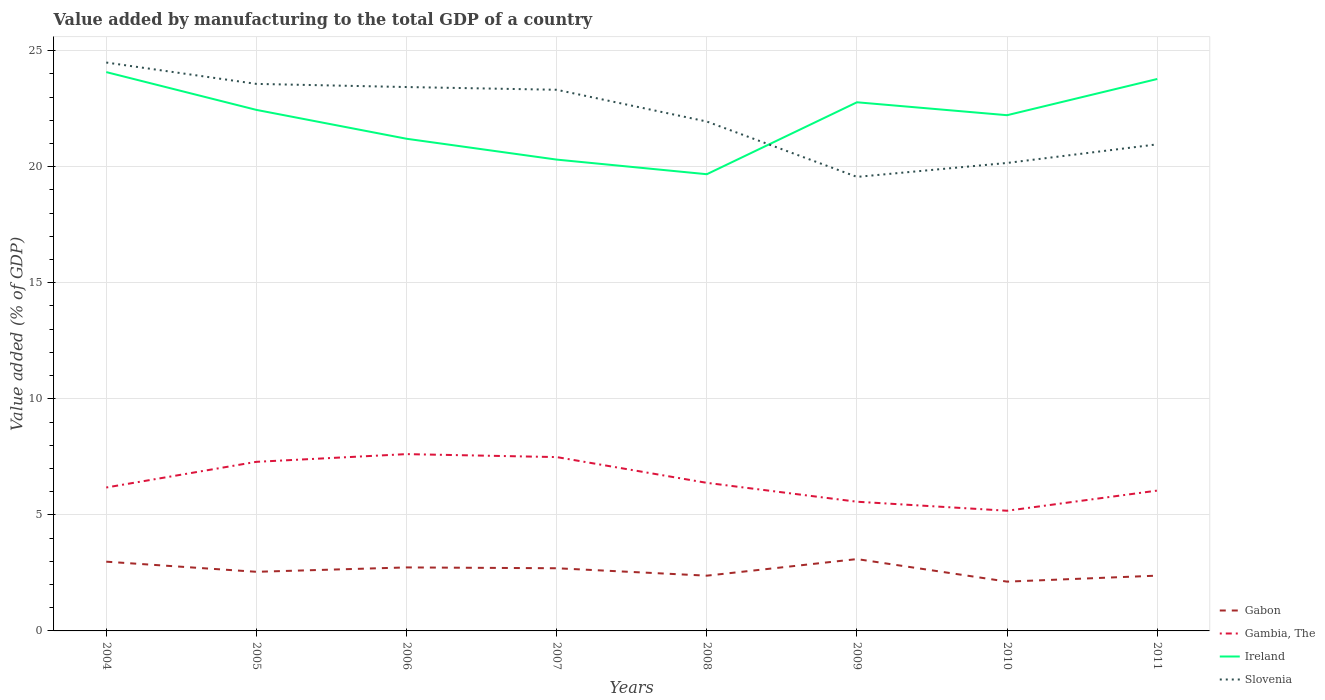How many different coloured lines are there?
Provide a short and direct response. 4. Does the line corresponding to Gambia, The intersect with the line corresponding to Slovenia?
Your answer should be compact. No. Across all years, what is the maximum value added by manufacturing to the total GDP in Gambia, The?
Offer a terse response. 5.18. What is the total value added by manufacturing to the total GDP in Ireland in the graph?
Your answer should be compact. 1.53. What is the difference between the highest and the second highest value added by manufacturing to the total GDP in Gambia, The?
Give a very brief answer. 2.44. Is the value added by manufacturing to the total GDP in Ireland strictly greater than the value added by manufacturing to the total GDP in Gambia, The over the years?
Offer a very short reply. No. How many lines are there?
Your answer should be very brief. 4. How many years are there in the graph?
Ensure brevity in your answer.  8. Are the values on the major ticks of Y-axis written in scientific E-notation?
Your response must be concise. No. Does the graph contain any zero values?
Your answer should be very brief. No. Does the graph contain grids?
Your answer should be very brief. Yes. How many legend labels are there?
Your answer should be very brief. 4. What is the title of the graph?
Give a very brief answer. Value added by manufacturing to the total GDP of a country. Does "Liberia" appear as one of the legend labels in the graph?
Provide a short and direct response. No. What is the label or title of the Y-axis?
Your answer should be very brief. Value added (% of GDP). What is the Value added (% of GDP) of Gabon in 2004?
Offer a terse response. 2.98. What is the Value added (% of GDP) of Gambia, The in 2004?
Keep it short and to the point. 6.18. What is the Value added (% of GDP) in Ireland in 2004?
Provide a succinct answer. 24.07. What is the Value added (% of GDP) in Slovenia in 2004?
Ensure brevity in your answer.  24.49. What is the Value added (% of GDP) of Gabon in 2005?
Provide a short and direct response. 2.55. What is the Value added (% of GDP) in Gambia, The in 2005?
Provide a short and direct response. 7.28. What is the Value added (% of GDP) in Ireland in 2005?
Your answer should be compact. 22.45. What is the Value added (% of GDP) of Slovenia in 2005?
Your answer should be very brief. 23.57. What is the Value added (% of GDP) of Gabon in 2006?
Offer a very short reply. 2.74. What is the Value added (% of GDP) of Gambia, The in 2006?
Provide a short and direct response. 7.62. What is the Value added (% of GDP) in Ireland in 2006?
Make the answer very short. 21.2. What is the Value added (% of GDP) of Slovenia in 2006?
Offer a terse response. 23.43. What is the Value added (% of GDP) in Gabon in 2007?
Your answer should be very brief. 2.7. What is the Value added (% of GDP) of Gambia, The in 2007?
Your answer should be very brief. 7.49. What is the Value added (% of GDP) in Ireland in 2007?
Make the answer very short. 20.31. What is the Value added (% of GDP) in Slovenia in 2007?
Offer a very short reply. 23.31. What is the Value added (% of GDP) in Gabon in 2008?
Offer a very short reply. 2.38. What is the Value added (% of GDP) of Gambia, The in 2008?
Ensure brevity in your answer.  6.38. What is the Value added (% of GDP) of Ireland in 2008?
Your response must be concise. 19.68. What is the Value added (% of GDP) in Slovenia in 2008?
Provide a short and direct response. 21.95. What is the Value added (% of GDP) in Gabon in 2009?
Make the answer very short. 3.1. What is the Value added (% of GDP) of Gambia, The in 2009?
Keep it short and to the point. 5.57. What is the Value added (% of GDP) of Ireland in 2009?
Offer a very short reply. 22.77. What is the Value added (% of GDP) in Slovenia in 2009?
Ensure brevity in your answer.  19.56. What is the Value added (% of GDP) in Gabon in 2010?
Your answer should be compact. 2.12. What is the Value added (% of GDP) in Gambia, The in 2010?
Keep it short and to the point. 5.18. What is the Value added (% of GDP) of Ireland in 2010?
Your answer should be very brief. 22.22. What is the Value added (% of GDP) of Slovenia in 2010?
Give a very brief answer. 20.16. What is the Value added (% of GDP) in Gabon in 2011?
Make the answer very short. 2.38. What is the Value added (% of GDP) in Gambia, The in 2011?
Ensure brevity in your answer.  6.05. What is the Value added (% of GDP) in Ireland in 2011?
Offer a very short reply. 23.78. What is the Value added (% of GDP) of Slovenia in 2011?
Offer a very short reply. 20.96. Across all years, what is the maximum Value added (% of GDP) of Gabon?
Your response must be concise. 3.1. Across all years, what is the maximum Value added (% of GDP) of Gambia, The?
Your answer should be compact. 7.62. Across all years, what is the maximum Value added (% of GDP) in Ireland?
Offer a terse response. 24.07. Across all years, what is the maximum Value added (% of GDP) of Slovenia?
Give a very brief answer. 24.49. Across all years, what is the minimum Value added (% of GDP) of Gabon?
Give a very brief answer. 2.12. Across all years, what is the minimum Value added (% of GDP) of Gambia, The?
Provide a short and direct response. 5.18. Across all years, what is the minimum Value added (% of GDP) of Ireland?
Ensure brevity in your answer.  19.68. Across all years, what is the minimum Value added (% of GDP) in Slovenia?
Ensure brevity in your answer.  19.56. What is the total Value added (% of GDP) of Gabon in the graph?
Offer a very short reply. 20.95. What is the total Value added (% of GDP) in Gambia, The in the graph?
Your answer should be very brief. 51.74. What is the total Value added (% of GDP) in Ireland in the graph?
Ensure brevity in your answer.  176.47. What is the total Value added (% of GDP) of Slovenia in the graph?
Make the answer very short. 177.43. What is the difference between the Value added (% of GDP) in Gabon in 2004 and that in 2005?
Your response must be concise. 0.44. What is the difference between the Value added (% of GDP) of Gambia, The in 2004 and that in 2005?
Offer a very short reply. -1.11. What is the difference between the Value added (% of GDP) of Ireland in 2004 and that in 2005?
Keep it short and to the point. 1.63. What is the difference between the Value added (% of GDP) in Slovenia in 2004 and that in 2005?
Make the answer very short. 0.92. What is the difference between the Value added (% of GDP) of Gabon in 2004 and that in 2006?
Give a very brief answer. 0.25. What is the difference between the Value added (% of GDP) in Gambia, The in 2004 and that in 2006?
Your answer should be very brief. -1.44. What is the difference between the Value added (% of GDP) of Ireland in 2004 and that in 2006?
Your answer should be compact. 2.87. What is the difference between the Value added (% of GDP) of Slovenia in 2004 and that in 2006?
Make the answer very short. 1.06. What is the difference between the Value added (% of GDP) of Gabon in 2004 and that in 2007?
Offer a terse response. 0.28. What is the difference between the Value added (% of GDP) of Gambia, The in 2004 and that in 2007?
Offer a terse response. -1.31. What is the difference between the Value added (% of GDP) of Ireland in 2004 and that in 2007?
Provide a succinct answer. 3.77. What is the difference between the Value added (% of GDP) of Slovenia in 2004 and that in 2007?
Provide a short and direct response. 1.17. What is the difference between the Value added (% of GDP) of Gabon in 2004 and that in 2008?
Ensure brevity in your answer.  0.6. What is the difference between the Value added (% of GDP) in Gambia, The in 2004 and that in 2008?
Keep it short and to the point. -0.2. What is the difference between the Value added (% of GDP) of Ireland in 2004 and that in 2008?
Provide a succinct answer. 4.4. What is the difference between the Value added (% of GDP) in Slovenia in 2004 and that in 2008?
Offer a very short reply. 2.54. What is the difference between the Value added (% of GDP) of Gabon in 2004 and that in 2009?
Your answer should be very brief. -0.11. What is the difference between the Value added (% of GDP) in Gambia, The in 2004 and that in 2009?
Your answer should be compact. 0.61. What is the difference between the Value added (% of GDP) in Ireland in 2004 and that in 2009?
Provide a succinct answer. 1.3. What is the difference between the Value added (% of GDP) in Slovenia in 2004 and that in 2009?
Your answer should be very brief. 4.93. What is the difference between the Value added (% of GDP) in Gabon in 2004 and that in 2010?
Your answer should be very brief. 0.86. What is the difference between the Value added (% of GDP) of Ireland in 2004 and that in 2010?
Provide a succinct answer. 1.86. What is the difference between the Value added (% of GDP) in Slovenia in 2004 and that in 2010?
Offer a very short reply. 4.33. What is the difference between the Value added (% of GDP) of Gabon in 2004 and that in 2011?
Offer a very short reply. 0.6. What is the difference between the Value added (% of GDP) in Gambia, The in 2004 and that in 2011?
Your response must be concise. 0.13. What is the difference between the Value added (% of GDP) of Ireland in 2004 and that in 2011?
Offer a terse response. 0.3. What is the difference between the Value added (% of GDP) in Slovenia in 2004 and that in 2011?
Offer a terse response. 3.52. What is the difference between the Value added (% of GDP) in Gabon in 2005 and that in 2006?
Provide a short and direct response. -0.19. What is the difference between the Value added (% of GDP) in Gambia, The in 2005 and that in 2006?
Provide a short and direct response. -0.33. What is the difference between the Value added (% of GDP) in Ireland in 2005 and that in 2006?
Your response must be concise. 1.24. What is the difference between the Value added (% of GDP) in Slovenia in 2005 and that in 2006?
Give a very brief answer. 0.14. What is the difference between the Value added (% of GDP) in Gabon in 2005 and that in 2007?
Make the answer very short. -0.15. What is the difference between the Value added (% of GDP) in Gambia, The in 2005 and that in 2007?
Your answer should be very brief. -0.2. What is the difference between the Value added (% of GDP) in Ireland in 2005 and that in 2007?
Your response must be concise. 2.14. What is the difference between the Value added (% of GDP) in Slovenia in 2005 and that in 2007?
Your answer should be compact. 0.25. What is the difference between the Value added (% of GDP) of Gabon in 2005 and that in 2008?
Give a very brief answer. 0.17. What is the difference between the Value added (% of GDP) of Gambia, The in 2005 and that in 2008?
Offer a very short reply. 0.91. What is the difference between the Value added (% of GDP) in Ireland in 2005 and that in 2008?
Offer a terse response. 2.77. What is the difference between the Value added (% of GDP) in Slovenia in 2005 and that in 2008?
Your response must be concise. 1.62. What is the difference between the Value added (% of GDP) in Gabon in 2005 and that in 2009?
Make the answer very short. -0.55. What is the difference between the Value added (% of GDP) in Gambia, The in 2005 and that in 2009?
Offer a terse response. 1.72. What is the difference between the Value added (% of GDP) of Ireland in 2005 and that in 2009?
Offer a very short reply. -0.33. What is the difference between the Value added (% of GDP) of Slovenia in 2005 and that in 2009?
Provide a succinct answer. 4.01. What is the difference between the Value added (% of GDP) of Gabon in 2005 and that in 2010?
Your answer should be very brief. 0.42. What is the difference between the Value added (% of GDP) of Gambia, The in 2005 and that in 2010?
Give a very brief answer. 2.11. What is the difference between the Value added (% of GDP) in Ireland in 2005 and that in 2010?
Your answer should be very brief. 0.23. What is the difference between the Value added (% of GDP) in Slovenia in 2005 and that in 2010?
Give a very brief answer. 3.41. What is the difference between the Value added (% of GDP) of Gabon in 2005 and that in 2011?
Provide a short and direct response. 0.17. What is the difference between the Value added (% of GDP) in Gambia, The in 2005 and that in 2011?
Your answer should be compact. 1.24. What is the difference between the Value added (% of GDP) in Ireland in 2005 and that in 2011?
Your answer should be compact. -1.33. What is the difference between the Value added (% of GDP) of Slovenia in 2005 and that in 2011?
Your response must be concise. 2.6. What is the difference between the Value added (% of GDP) in Gabon in 2006 and that in 2007?
Provide a succinct answer. 0.04. What is the difference between the Value added (% of GDP) of Gambia, The in 2006 and that in 2007?
Ensure brevity in your answer.  0.13. What is the difference between the Value added (% of GDP) in Ireland in 2006 and that in 2007?
Make the answer very short. 0.9. What is the difference between the Value added (% of GDP) in Slovenia in 2006 and that in 2007?
Your response must be concise. 0.12. What is the difference between the Value added (% of GDP) of Gabon in 2006 and that in 2008?
Give a very brief answer. 0.36. What is the difference between the Value added (% of GDP) in Gambia, The in 2006 and that in 2008?
Provide a succinct answer. 1.24. What is the difference between the Value added (% of GDP) of Ireland in 2006 and that in 2008?
Make the answer very short. 1.53. What is the difference between the Value added (% of GDP) of Slovenia in 2006 and that in 2008?
Your answer should be very brief. 1.49. What is the difference between the Value added (% of GDP) of Gabon in 2006 and that in 2009?
Offer a very short reply. -0.36. What is the difference between the Value added (% of GDP) in Gambia, The in 2006 and that in 2009?
Offer a terse response. 2.05. What is the difference between the Value added (% of GDP) of Ireland in 2006 and that in 2009?
Your response must be concise. -1.57. What is the difference between the Value added (% of GDP) of Slovenia in 2006 and that in 2009?
Your response must be concise. 3.87. What is the difference between the Value added (% of GDP) of Gabon in 2006 and that in 2010?
Your response must be concise. 0.61. What is the difference between the Value added (% of GDP) of Gambia, The in 2006 and that in 2010?
Give a very brief answer. 2.44. What is the difference between the Value added (% of GDP) of Ireland in 2006 and that in 2010?
Your answer should be very brief. -1.01. What is the difference between the Value added (% of GDP) of Slovenia in 2006 and that in 2010?
Ensure brevity in your answer.  3.27. What is the difference between the Value added (% of GDP) of Gabon in 2006 and that in 2011?
Keep it short and to the point. 0.35. What is the difference between the Value added (% of GDP) in Gambia, The in 2006 and that in 2011?
Offer a terse response. 1.57. What is the difference between the Value added (% of GDP) in Ireland in 2006 and that in 2011?
Your response must be concise. -2.57. What is the difference between the Value added (% of GDP) in Slovenia in 2006 and that in 2011?
Offer a very short reply. 2.47. What is the difference between the Value added (% of GDP) of Gabon in 2007 and that in 2008?
Your response must be concise. 0.32. What is the difference between the Value added (% of GDP) in Gambia, The in 2007 and that in 2008?
Your answer should be very brief. 1.11. What is the difference between the Value added (% of GDP) of Ireland in 2007 and that in 2008?
Your answer should be very brief. 0.63. What is the difference between the Value added (% of GDP) in Slovenia in 2007 and that in 2008?
Make the answer very short. 1.37. What is the difference between the Value added (% of GDP) in Gabon in 2007 and that in 2009?
Your answer should be compact. -0.4. What is the difference between the Value added (% of GDP) of Gambia, The in 2007 and that in 2009?
Your answer should be very brief. 1.92. What is the difference between the Value added (% of GDP) in Ireland in 2007 and that in 2009?
Give a very brief answer. -2.47. What is the difference between the Value added (% of GDP) in Slovenia in 2007 and that in 2009?
Make the answer very short. 3.75. What is the difference between the Value added (% of GDP) in Gabon in 2007 and that in 2010?
Provide a succinct answer. 0.58. What is the difference between the Value added (% of GDP) in Gambia, The in 2007 and that in 2010?
Your answer should be compact. 2.31. What is the difference between the Value added (% of GDP) in Ireland in 2007 and that in 2010?
Keep it short and to the point. -1.91. What is the difference between the Value added (% of GDP) in Slovenia in 2007 and that in 2010?
Give a very brief answer. 3.15. What is the difference between the Value added (% of GDP) of Gabon in 2007 and that in 2011?
Provide a short and direct response. 0.32. What is the difference between the Value added (% of GDP) in Gambia, The in 2007 and that in 2011?
Offer a terse response. 1.44. What is the difference between the Value added (% of GDP) in Ireland in 2007 and that in 2011?
Give a very brief answer. -3.47. What is the difference between the Value added (% of GDP) in Slovenia in 2007 and that in 2011?
Ensure brevity in your answer.  2.35. What is the difference between the Value added (% of GDP) in Gabon in 2008 and that in 2009?
Your answer should be very brief. -0.71. What is the difference between the Value added (% of GDP) of Gambia, The in 2008 and that in 2009?
Provide a succinct answer. 0.81. What is the difference between the Value added (% of GDP) in Ireland in 2008 and that in 2009?
Your answer should be compact. -3.1. What is the difference between the Value added (% of GDP) of Slovenia in 2008 and that in 2009?
Give a very brief answer. 2.39. What is the difference between the Value added (% of GDP) of Gabon in 2008 and that in 2010?
Provide a succinct answer. 0.26. What is the difference between the Value added (% of GDP) of Gambia, The in 2008 and that in 2010?
Offer a very short reply. 1.2. What is the difference between the Value added (% of GDP) in Ireland in 2008 and that in 2010?
Provide a succinct answer. -2.54. What is the difference between the Value added (% of GDP) of Slovenia in 2008 and that in 2010?
Provide a succinct answer. 1.78. What is the difference between the Value added (% of GDP) of Gabon in 2008 and that in 2011?
Make the answer very short. -0. What is the difference between the Value added (% of GDP) in Gambia, The in 2008 and that in 2011?
Give a very brief answer. 0.33. What is the difference between the Value added (% of GDP) of Ireland in 2008 and that in 2011?
Make the answer very short. -4.1. What is the difference between the Value added (% of GDP) of Slovenia in 2008 and that in 2011?
Your answer should be compact. 0.98. What is the difference between the Value added (% of GDP) of Gabon in 2009 and that in 2010?
Provide a short and direct response. 0.97. What is the difference between the Value added (% of GDP) in Gambia, The in 2009 and that in 2010?
Ensure brevity in your answer.  0.39. What is the difference between the Value added (% of GDP) in Ireland in 2009 and that in 2010?
Your answer should be very brief. 0.56. What is the difference between the Value added (% of GDP) in Slovenia in 2009 and that in 2010?
Offer a terse response. -0.6. What is the difference between the Value added (% of GDP) in Gabon in 2009 and that in 2011?
Your answer should be very brief. 0.71. What is the difference between the Value added (% of GDP) in Gambia, The in 2009 and that in 2011?
Make the answer very short. -0.48. What is the difference between the Value added (% of GDP) of Ireland in 2009 and that in 2011?
Give a very brief answer. -1. What is the difference between the Value added (% of GDP) in Slovenia in 2009 and that in 2011?
Offer a terse response. -1.4. What is the difference between the Value added (% of GDP) in Gabon in 2010 and that in 2011?
Your response must be concise. -0.26. What is the difference between the Value added (% of GDP) in Gambia, The in 2010 and that in 2011?
Offer a very short reply. -0.87. What is the difference between the Value added (% of GDP) of Ireland in 2010 and that in 2011?
Provide a succinct answer. -1.56. What is the difference between the Value added (% of GDP) of Slovenia in 2010 and that in 2011?
Ensure brevity in your answer.  -0.8. What is the difference between the Value added (% of GDP) in Gabon in 2004 and the Value added (% of GDP) in Gambia, The in 2005?
Offer a very short reply. -4.3. What is the difference between the Value added (% of GDP) in Gabon in 2004 and the Value added (% of GDP) in Ireland in 2005?
Keep it short and to the point. -19.46. What is the difference between the Value added (% of GDP) of Gabon in 2004 and the Value added (% of GDP) of Slovenia in 2005?
Offer a very short reply. -20.58. What is the difference between the Value added (% of GDP) in Gambia, The in 2004 and the Value added (% of GDP) in Ireland in 2005?
Offer a terse response. -16.27. What is the difference between the Value added (% of GDP) in Gambia, The in 2004 and the Value added (% of GDP) in Slovenia in 2005?
Offer a terse response. -17.39. What is the difference between the Value added (% of GDP) of Ireland in 2004 and the Value added (% of GDP) of Slovenia in 2005?
Your answer should be very brief. 0.51. What is the difference between the Value added (% of GDP) of Gabon in 2004 and the Value added (% of GDP) of Gambia, The in 2006?
Your response must be concise. -4.63. What is the difference between the Value added (% of GDP) in Gabon in 2004 and the Value added (% of GDP) in Ireland in 2006?
Give a very brief answer. -18.22. What is the difference between the Value added (% of GDP) in Gabon in 2004 and the Value added (% of GDP) in Slovenia in 2006?
Provide a short and direct response. -20.45. What is the difference between the Value added (% of GDP) of Gambia, The in 2004 and the Value added (% of GDP) of Ireland in 2006?
Your answer should be very brief. -15.02. What is the difference between the Value added (% of GDP) in Gambia, The in 2004 and the Value added (% of GDP) in Slovenia in 2006?
Provide a short and direct response. -17.25. What is the difference between the Value added (% of GDP) of Ireland in 2004 and the Value added (% of GDP) of Slovenia in 2006?
Provide a short and direct response. 0.64. What is the difference between the Value added (% of GDP) in Gabon in 2004 and the Value added (% of GDP) in Gambia, The in 2007?
Make the answer very short. -4.51. What is the difference between the Value added (% of GDP) of Gabon in 2004 and the Value added (% of GDP) of Ireland in 2007?
Give a very brief answer. -17.32. What is the difference between the Value added (% of GDP) of Gabon in 2004 and the Value added (% of GDP) of Slovenia in 2007?
Ensure brevity in your answer.  -20.33. What is the difference between the Value added (% of GDP) of Gambia, The in 2004 and the Value added (% of GDP) of Ireland in 2007?
Make the answer very short. -14.13. What is the difference between the Value added (% of GDP) of Gambia, The in 2004 and the Value added (% of GDP) of Slovenia in 2007?
Make the answer very short. -17.14. What is the difference between the Value added (% of GDP) of Ireland in 2004 and the Value added (% of GDP) of Slovenia in 2007?
Make the answer very short. 0.76. What is the difference between the Value added (% of GDP) in Gabon in 2004 and the Value added (% of GDP) in Gambia, The in 2008?
Your response must be concise. -3.4. What is the difference between the Value added (% of GDP) in Gabon in 2004 and the Value added (% of GDP) in Ireland in 2008?
Offer a terse response. -16.69. What is the difference between the Value added (% of GDP) of Gabon in 2004 and the Value added (% of GDP) of Slovenia in 2008?
Make the answer very short. -18.96. What is the difference between the Value added (% of GDP) of Gambia, The in 2004 and the Value added (% of GDP) of Ireland in 2008?
Provide a short and direct response. -13.5. What is the difference between the Value added (% of GDP) of Gambia, The in 2004 and the Value added (% of GDP) of Slovenia in 2008?
Your response must be concise. -15.77. What is the difference between the Value added (% of GDP) in Ireland in 2004 and the Value added (% of GDP) in Slovenia in 2008?
Provide a short and direct response. 2.13. What is the difference between the Value added (% of GDP) of Gabon in 2004 and the Value added (% of GDP) of Gambia, The in 2009?
Your response must be concise. -2.58. What is the difference between the Value added (% of GDP) in Gabon in 2004 and the Value added (% of GDP) in Ireland in 2009?
Make the answer very short. -19.79. What is the difference between the Value added (% of GDP) of Gabon in 2004 and the Value added (% of GDP) of Slovenia in 2009?
Make the answer very short. -16.58. What is the difference between the Value added (% of GDP) in Gambia, The in 2004 and the Value added (% of GDP) in Ireland in 2009?
Your answer should be very brief. -16.6. What is the difference between the Value added (% of GDP) in Gambia, The in 2004 and the Value added (% of GDP) in Slovenia in 2009?
Provide a short and direct response. -13.38. What is the difference between the Value added (% of GDP) in Ireland in 2004 and the Value added (% of GDP) in Slovenia in 2009?
Offer a very short reply. 4.51. What is the difference between the Value added (% of GDP) of Gabon in 2004 and the Value added (% of GDP) of Gambia, The in 2010?
Provide a short and direct response. -2.19. What is the difference between the Value added (% of GDP) in Gabon in 2004 and the Value added (% of GDP) in Ireland in 2010?
Your answer should be very brief. -19.23. What is the difference between the Value added (% of GDP) of Gabon in 2004 and the Value added (% of GDP) of Slovenia in 2010?
Keep it short and to the point. -17.18. What is the difference between the Value added (% of GDP) in Gambia, The in 2004 and the Value added (% of GDP) in Ireland in 2010?
Make the answer very short. -16.04. What is the difference between the Value added (% of GDP) in Gambia, The in 2004 and the Value added (% of GDP) in Slovenia in 2010?
Offer a terse response. -13.98. What is the difference between the Value added (% of GDP) of Ireland in 2004 and the Value added (% of GDP) of Slovenia in 2010?
Your response must be concise. 3.91. What is the difference between the Value added (% of GDP) of Gabon in 2004 and the Value added (% of GDP) of Gambia, The in 2011?
Ensure brevity in your answer.  -3.06. What is the difference between the Value added (% of GDP) of Gabon in 2004 and the Value added (% of GDP) of Ireland in 2011?
Ensure brevity in your answer.  -20.79. What is the difference between the Value added (% of GDP) of Gabon in 2004 and the Value added (% of GDP) of Slovenia in 2011?
Offer a terse response. -17.98. What is the difference between the Value added (% of GDP) of Gambia, The in 2004 and the Value added (% of GDP) of Ireland in 2011?
Your answer should be compact. -17.6. What is the difference between the Value added (% of GDP) of Gambia, The in 2004 and the Value added (% of GDP) of Slovenia in 2011?
Give a very brief answer. -14.78. What is the difference between the Value added (% of GDP) of Ireland in 2004 and the Value added (% of GDP) of Slovenia in 2011?
Provide a short and direct response. 3.11. What is the difference between the Value added (% of GDP) in Gabon in 2005 and the Value added (% of GDP) in Gambia, The in 2006?
Offer a terse response. -5.07. What is the difference between the Value added (% of GDP) of Gabon in 2005 and the Value added (% of GDP) of Ireland in 2006?
Ensure brevity in your answer.  -18.66. What is the difference between the Value added (% of GDP) of Gabon in 2005 and the Value added (% of GDP) of Slovenia in 2006?
Make the answer very short. -20.88. What is the difference between the Value added (% of GDP) of Gambia, The in 2005 and the Value added (% of GDP) of Ireland in 2006?
Give a very brief answer. -13.92. What is the difference between the Value added (% of GDP) in Gambia, The in 2005 and the Value added (% of GDP) in Slovenia in 2006?
Offer a terse response. -16.15. What is the difference between the Value added (% of GDP) in Ireland in 2005 and the Value added (% of GDP) in Slovenia in 2006?
Provide a succinct answer. -0.98. What is the difference between the Value added (% of GDP) in Gabon in 2005 and the Value added (% of GDP) in Gambia, The in 2007?
Your answer should be compact. -4.94. What is the difference between the Value added (% of GDP) of Gabon in 2005 and the Value added (% of GDP) of Ireland in 2007?
Offer a very short reply. -17.76. What is the difference between the Value added (% of GDP) in Gabon in 2005 and the Value added (% of GDP) in Slovenia in 2007?
Provide a short and direct response. -20.77. What is the difference between the Value added (% of GDP) in Gambia, The in 2005 and the Value added (% of GDP) in Ireland in 2007?
Keep it short and to the point. -13.02. What is the difference between the Value added (% of GDP) in Gambia, The in 2005 and the Value added (% of GDP) in Slovenia in 2007?
Offer a very short reply. -16.03. What is the difference between the Value added (% of GDP) in Ireland in 2005 and the Value added (% of GDP) in Slovenia in 2007?
Provide a succinct answer. -0.87. What is the difference between the Value added (% of GDP) in Gabon in 2005 and the Value added (% of GDP) in Gambia, The in 2008?
Ensure brevity in your answer.  -3.83. What is the difference between the Value added (% of GDP) in Gabon in 2005 and the Value added (% of GDP) in Ireland in 2008?
Your response must be concise. -17.13. What is the difference between the Value added (% of GDP) of Gabon in 2005 and the Value added (% of GDP) of Slovenia in 2008?
Make the answer very short. -19.4. What is the difference between the Value added (% of GDP) in Gambia, The in 2005 and the Value added (% of GDP) in Ireland in 2008?
Provide a succinct answer. -12.39. What is the difference between the Value added (% of GDP) in Gambia, The in 2005 and the Value added (% of GDP) in Slovenia in 2008?
Offer a very short reply. -14.66. What is the difference between the Value added (% of GDP) in Ireland in 2005 and the Value added (% of GDP) in Slovenia in 2008?
Keep it short and to the point. 0.5. What is the difference between the Value added (% of GDP) in Gabon in 2005 and the Value added (% of GDP) in Gambia, The in 2009?
Provide a short and direct response. -3.02. What is the difference between the Value added (% of GDP) of Gabon in 2005 and the Value added (% of GDP) of Ireland in 2009?
Your answer should be compact. -20.23. What is the difference between the Value added (% of GDP) in Gabon in 2005 and the Value added (% of GDP) in Slovenia in 2009?
Your answer should be compact. -17.01. What is the difference between the Value added (% of GDP) of Gambia, The in 2005 and the Value added (% of GDP) of Ireland in 2009?
Provide a short and direct response. -15.49. What is the difference between the Value added (% of GDP) in Gambia, The in 2005 and the Value added (% of GDP) in Slovenia in 2009?
Your response must be concise. -12.28. What is the difference between the Value added (% of GDP) in Ireland in 2005 and the Value added (% of GDP) in Slovenia in 2009?
Ensure brevity in your answer.  2.89. What is the difference between the Value added (% of GDP) of Gabon in 2005 and the Value added (% of GDP) of Gambia, The in 2010?
Provide a succinct answer. -2.63. What is the difference between the Value added (% of GDP) in Gabon in 2005 and the Value added (% of GDP) in Ireland in 2010?
Your answer should be compact. -19.67. What is the difference between the Value added (% of GDP) in Gabon in 2005 and the Value added (% of GDP) in Slovenia in 2010?
Your answer should be very brief. -17.61. What is the difference between the Value added (% of GDP) in Gambia, The in 2005 and the Value added (% of GDP) in Ireland in 2010?
Provide a succinct answer. -14.93. What is the difference between the Value added (% of GDP) in Gambia, The in 2005 and the Value added (% of GDP) in Slovenia in 2010?
Provide a short and direct response. -12.88. What is the difference between the Value added (% of GDP) of Ireland in 2005 and the Value added (% of GDP) of Slovenia in 2010?
Your answer should be very brief. 2.29. What is the difference between the Value added (% of GDP) of Gabon in 2005 and the Value added (% of GDP) of Gambia, The in 2011?
Your response must be concise. -3.5. What is the difference between the Value added (% of GDP) in Gabon in 2005 and the Value added (% of GDP) in Ireland in 2011?
Your answer should be compact. -21.23. What is the difference between the Value added (% of GDP) of Gabon in 2005 and the Value added (% of GDP) of Slovenia in 2011?
Offer a very short reply. -18.41. What is the difference between the Value added (% of GDP) of Gambia, The in 2005 and the Value added (% of GDP) of Ireland in 2011?
Offer a terse response. -16.49. What is the difference between the Value added (% of GDP) in Gambia, The in 2005 and the Value added (% of GDP) in Slovenia in 2011?
Offer a terse response. -13.68. What is the difference between the Value added (% of GDP) in Ireland in 2005 and the Value added (% of GDP) in Slovenia in 2011?
Keep it short and to the point. 1.48. What is the difference between the Value added (% of GDP) of Gabon in 2006 and the Value added (% of GDP) of Gambia, The in 2007?
Your response must be concise. -4.75. What is the difference between the Value added (% of GDP) in Gabon in 2006 and the Value added (% of GDP) in Ireland in 2007?
Offer a very short reply. -17.57. What is the difference between the Value added (% of GDP) of Gabon in 2006 and the Value added (% of GDP) of Slovenia in 2007?
Offer a terse response. -20.58. What is the difference between the Value added (% of GDP) in Gambia, The in 2006 and the Value added (% of GDP) in Ireland in 2007?
Offer a very short reply. -12.69. What is the difference between the Value added (% of GDP) in Gambia, The in 2006 and the Value added (% of GDP) in Slovenia in 2007?
Your answer should be compact. -15.7. What is the difference between the Value added (% of GDP) in Ireland in 2006 and the Value added (% of GDP) in Slovenia in 2007?
Your answer should be very brief. -2.11. What is the difference between the Value added (% of GDP) of Gabon in 2006 and the Value added (% of GDP) of Gambia, The in 2008?
Your answer should be very brief. -3.64. What is the difference between the Value added (% of GDP) in Gabon in 2006 and the Value added (% of GDP) in Ireland in 2008?
Keep it short and to the point. -16.94. What is the difference between the Value added (% of GDP) in Gabon in 2006 and the Value added (% of GDP) in Slovenia in 2008?
Your response must be concise. -19.21. What is the difference between the Value added (% of GDP) in Gambia, The in 2006 and the Value added (% of GDP) in Ireland in 2008?
Offer a terse response. -12.06. What is the difference between the Value added (% of GDP) in Gambia, The in 2006 and the Value added (% of GDP) in Slovenia in 2008?
Keep it short and to the point. -14.33. What is the difference between the Value added (% of GDP) of Ireland in 2006 and the Value added (% of GDP) of Slovenia in 2008?
Give a very brief answer. -0.74. What is the difference between the Value added (% of GDP) in Gabon in 2006 and the Value added (% of GDP) in Gambia, The in 2009?
Your answer should be compact. -2.83. What is the difference between the Value added (% of GDP) of Gabon in 2006 and the Value added (% of GDP) of Ireland in 2009?
Ensure brevity in your answer.  -20.04. What is the difference between the Value added (% of GDP) of Gabon in 2006 and the Value added (% of GDP) of Slovenia in 2009?
Keep it short and to the point. -16.82. What is the difference between the Value added (% of GDP) of Gambia, The in 2006 and the Value added (% of GDP) of Ireland in 2009?
Keep it short and to the point. -15.16. What is the difference between the Value added (% of GDP) in Gambia, The in 2006 and the Value added (% of GDP) in Slovenia in 2009?
Your answer should be very brief. -11.94. What is the difference between the Value added (% of GDP) in Ireland in 2006 and the Value added (% of GDP) in Slovenia in 2009?
Give a very brief answer. 1.64. What is the difference between the Value added (% of GDP) in Gabon in 2006 and the Value added (% of GDP) in Gambia, The in 2010?
Give a very brief answer. -2.44. What is the difference between the Value added (% of GDP) in Gabon in 2006 and the Value added (% of GDP) in Ireland in 2010?
Give a very brief answer. -19.48. What is the difference between the Value added (% of GDP) of Gabon in 2006 and the Value added (% of GDP) of Slovenia in 2010?
Keep it short and to the point. -17.43. What is the difference between the Value added (% of GDP) of Gambia, The in 2006 and the Value added (% of GDP) of Ireland in 2010?
Provide a short and direct response. -14.6. What is the difference between the Value added (% of GDP) in Gambia, The in 2006 and the Value added (% of GDP) in Slovenia in 2010?
Give a very brief answer. -12.54. What is the difference between the Value added (% of GDP) of Ireland in 2006 and the Value added (% of GDP) of Slovenia in 2010?
Your answer should be very brief. 1.04. What is the difference between the Value added (% of GDP) of Gabon in 2006 and the Value added (% of GDP) of Gambia, The in 2011?
Give a very brief answer. -3.31. What is the difference between the Value added (% of GDP) in Gabon in 2006 and the Value added (% of GDP) in Ireland in 2011?
Give a very brief answer. -21.04. What is the difference between the Value added (% of GDP) in Gabon in 2006 and the Value added (% of GDP) in Slovenia in 2011?
Provide a succinct answer. -18.23. What is the difference between the Value added (% of GDP) of Gambia, The in 2006 and the Value added (% of GDP) of Ireland in 2011?
Make the answer very short. -16.16. What is the difference between the Value added (% of GDP) of Gambia, The in 2006 and the Value added (% of GDP) of Slovenia in 2011?
Offer a very short reply. -13.35. What is the difference between the Value added (% of GDP) of Ireland in 2006 and the Value added (% of GDP) of Slovenia in 2011?
Keep it short and to the point. 0.24. What is the difference between the Value added (% of GDP) in Gabon in 2007 and the Value added (% of GDP) in Gambia, The in 2008?
Make the answer very short. -3.68. What is the difference between the Value added (% of GDP) in Gabon in 2007 and the Value added (% of GDP) in Ireland in 2008?
Provide a succinct answer. -16.98. What is the difference between the Value added (% of GDP) of Gabon in 2007 and the Value added (% of GDP) of Slovenia in 2008?
Offer a terse response. -19.25. What is the difference between the Value added (% of GDP) in Gambia, The in 2007 and the Value added (% of GDP) in Ireland in 2008?
Ensure brevity in your answer.  -12.19. What is the difference between the Value added (% of GDP) of Gambia, The in 2007 and the Value added (% of GDP) of Slovenia in 2008?
Give a very brief answer. -14.46. What is the difference between the Value added (% of GDP) of Ireland in 2007 and the Value added (% of GDP) of Slovenia in 2008?
Your response must be concise. -1.64. What is the difference between the Value added (% of GDP) of Gabon in 2007 and the Value added (% of GDP) of Gambia, The in 2009?
Ensure brevity in your answer.  -2.87. What is the difference between the Value added (% of GDP) in Gabon in 2007 and the Value added (% of GDP) in Ireland in 2009?
Your answer should be compact. -20.07. What is the difference between the Value added (% of GDP) in Gabon in 2007 and the Value added (% of GDP) in Slovenia in 2009?
Ensure brevity in your answer.  -16.86. What is the difference between the Value added (% of GDP) of Gambia, The in 2007 and the Value added (% of GDP) of Ireland in 2009?
Make the answer very short. -15.29. What is the difference between the Value added (% of GDP) in Gambia, The in 2007 and the Value added (% of GDP) in Slovenia in 2009?
Keep it short and to the point. -12.07. What is the difference between the Value added (% of GDP) in Ireland in 2007 and the Value added (% of GDP) in Slovenia in 2009?
Your answer should be very brief. 0.75. What is the difference between the Value added (% of GDP) in Gabon in 2007 and the Value added (% of GDP) in Gambia, The in 2010?
Offer a terse response. -2.48. What is the difference between the Value added (% of GDP) of Gabon in 2007 and the Value added (% of GDP) of Ireland in 2010?
Provide a succinct answer. -19.52. What is the difference between the Value added (% of GDP) in Gabon in 2007 and the Value added (% of GDP) in Slovenia in 2010?
Provide a short and direct response. -17.46. What is the difference between the Value added (% of GDP) in Gambia, The in 2007 and the Value added (% of GDP) in Ireland in 2010?
Make the answer very short. -14.73. What is the difference between the Value added (% of GDP) of Gambia, The in 2007 and the Value added (% of GDP) of Slovenia in 2010?
Keep it short and to the point. -12.67. What is the difference between the Value added (% of GDP) of Ireland in 2007 and the Value added (% of GDP) of Slovenia in 2010?
Your response must be concise. 0.14. What is the difference between the Value added (% of GDP) in Gabon in 2007 and the Value added (% of GDP) in Gambia, The in 2011?
Your answer should be very brief. -3.35. What is the difference between the Value added (% of GDP) of Gabon in 2007 and the Value added (% of GDP) of Ireland in 2011?
Keep it short and to the point. -21.08. What is the difference between the Value added (% of GDP) in Gabon in 2007 and the Value added (% of GDP) in Slovenia in 2011?
Your response must be concise. -18.26. What is the difference between the Value added (% of GDP) in Gambia, The in 2007 and the Value added (% of GDP) in Ireland in 2011?
Your response must be concise. -16.29. What is the difference between the Value added (% of GDP) in Gambia, The in 2007 and the Value added (% of GDP) in Slovenia in 2011?
Offer a very short reply. -13.47. What is the difference between the Value added (% of GDP) in Ireland in 2007 and the Value added (% of GDP) in Slovenia in 2011?
Offer a very short reply. -0.66. What is the difference between the Value added (% of GDP) in Gabon in 2008 and the Value added (% of GDP) in Gambia, The in 2009?
Your answer should be compact. -3.19. What is the difference between the Value added (% of GDP) of Gabon in 2008 and the Value added (% of GDP) of Ireland in 2009?
Offer a very short reply. -20.39. What is the difference between the Value added (% of GDP) in Gabon in 2008 and the Value added (% of GDP) in Slovenia in 2009?
Your answer should be compact. -17.18. What is the difference between the Value added (% of GDP) in Gambia, The in 2008 and the Value added (% of GDP) in Ireland in 2009?
Your response must be concise. -16.4. What is the difference between the Value added (% of GDP) of Gambia, The in 2008 and the Value added (% of GDP) of Slovenia in 2009?
Make the answer very short. -13.18. What is the difference between the Value added (% of GDP) of Ireland in 2008 and the Value added (% of GDP) of Slovenia in 2009?
Provide a succinct answer. 0.12. What is the difference between the Value added (% of GDP) in Gabon in 2008 and the Value added (% of GDP) in Gambia, The in 2010?
Offer a very short reply. -2.8. What is the difference between the Value added (% of GDP) in Gabon in 2008 and the Value added (% of GDP) in Ireland in 2010?
Ensure brevity in your answer.  -19.84. What is the difference between the Value added (% of GDP) of Gabon in 2008 and the Value added (% of GDP) of Slovenia in 2010?
Your answer should be compact. -17.78. What is the difference between the Value added (% of GDP) of Gambia, The in 2008 and the Value added (% of GDP) of Ireland in 2010?
Offer a terse response. -15.84. What is the difference between the Value added (% of GDP) in Gambia, The in 2008 and the Value added (% of GDP) in Slovenia in 2010?
Give a very brief answer. -13.78. What is the difference between the Value added (% of GDP) in Ireland in 2008 and the Value added (% of GDP) in Slovenia in 2010?
Provide a short and direct response. -0.49. What is the difference between the Value added (% of GDP) in Gabon in 2008 and the Value added (% of GDP) in Gambia, The in 2011?
Offer a terse response. -3.66. What is the difference between the Value added (% of GDP) in Gabon in 2008 and the Value added (% of GDP) in Ireland in 2011?
Provide a succinct answer. -21.4. What is the difference between the Value added (% of GDP) in Gabon in 2008 and the Value added (% of GDP) in Slovenia in 2011?
Offer a very short reply. -18.58. What is the difference between the Value added (% of GDP) of Gambia, The in 2008 and the Value added (% of GDP) of Ireland in 2011?
Ensure brevity in your answer.  -17.4. What is the difference between the Value added (% of GDP) in Gambia, The in 2008 and the Value added (% of GDP) in Slovenia in 2011?
Keep it short and to the point. -14.58. What is the difference between the Value added (% of GDP) of Ireland in 2008 and the Value added (% of GDP) of Slovenia in 2011?
Ensure brevity in your answer.  -1.29. What is the difference between the Value added (% of GDP) in Gabon in 2009 and the Value added (% of GDP) in Gambia, The in 2010?
Offer a very short reply. -2.08. What is the difference between the Value added (% of GDP) in Gabon in 2009 and the Value added (% of GDP) in Ireland in 2010?
Your response must be concise. -19.12. What is the difference between the Value added (% of GDP) of Gabon in 2009 and the Value added (% of GDP) of Slovenia in 2010?
Your response must be concise. -17.07. What is the difference between the Value added (% of GDP) in Gambia, The in 2009 and the Value added (% of GDP) in Ireland in 2010?
Provide a succinct answer. -16.65. What is the difference between the Value added (% of GDP) in Gambia, The in 2009 and the Value added (% of GDP) in Slovenia in 2010?
Offer a terse response. -14.59. What is the difference between the Value added (% of GDP) in Ireland in 2009 and the Value added (% of GDP) in Slovenia in 2010?
Make the answer very short. 2.61. What is the difference between the Value added (% of GDP) in Gabon in 2009 and the Value added (% of GDP) in Gambia, The in 2011?
Your answer should be very brief. -2.95. What is the difference between the Value added (% of GDP) in Gabon in 2009 and the Value added (% of GDP) in Ireland in 2011?
Provide a short and direct response. -20.68. What is the difference between the Value added (% of GDP) in Gabon in 2009 and the Value added (% of GDP) in Slovenia in 2011?
Offer a very short reply. -17.87. What is the difference between the Value added (% of GDP) in Gambia, The in 2009 and the Value added (% of GDP) in Ireland in 2011?
Provide a succinct answer. -18.21. What is the difference between the Value added (% of GDP) of Gambia, The in 2009 and the Value added (% of GDP) of Slovenia in 2011?
Your response must be concise. -15.4. What is the difference between the Value added (% of GDP) of Ireland in 2009 and the Value added (% of GDP) of Slovenia in 2011?
Provide a succinct answer. 1.81. What is the difference between the Value added (% of GDP) in Gabon in 2010 and the Value added (% of GDP) in Gambia, The in 2011?
Offer a very short reply. -3.92. What is the difference between the Value added (% of GDP) in Gabon in 2010 and the Value added (% of GDP) in Ireland in 2011?
Your answer should be very brief. -21.65. What is the difference between the Value added (% of GDP) of Gabon in 2010 and the Value added (% of GDP) of Slovenia in 2011?
Your response must be concise. -18.84. What is the difference between the Value added (% of GDP) in Gambia, The in 2010 and the Value added (% of GDP) in Ireland in 2011?
Make the answer very short. -18.6. What is the difference between the Value added (% of GDP) of Gambia, The in 2010 and the Value added (% of GDP) of Slovenia in 2011?
Keep it short and to the point. -15.78. What is the difference between the Value added (% of GDP) in Ireland in 2010 and the Value added (% of GDP) in Slovenia in 2011?
Your answer should be compact. 1.26. What is the average Value added (% of GDP) in Gabon per year?
Ensure brevity in your answer.  2.62. What is the average Value added (% of GDP) in Gambia, The per year?
Offer a terse response. 6.47. What is the average Value added (% of GDP) in Ireland per year?
Your response must be concise. 22.06. What is the average Value added (% of GDP) of Slovenia per year?
Give a very brief answer. 22.18. In the year 2004, what is the difference between the Value added (% of GDP) in Gabon and Value added (% of GDP) in Gambia, The?
Your answer should be very brief. -3.2. In the year 2004, what is the difference between the Value added (% of GDP) of Gabon and Value added (% of GDP) of Ireland?
Provide a short and direct response. -21.09. In the year 2004, what is the difference between the Value added (% of GDP) of Gabon and Value added (% of GDP) of Slovenia?
Keep it short and to the point. -21.5. In the year 2004, what is the difference between the Value added (% of GDP) of Gambia, The and Value added (% of GDP) of Ireland?
Your answer should be very brief. -17.9. In the year 2004, what is the difference between the Value added (% of GDP) in Gambia, The and Value added (% of GDP) in Slovenia?
Give a very brief answer. -18.31. In the year 2004, what is the difference between the Value added (% of GDP) in Ireland and Value added (% of GDP) in Slovenia?
Offer a terse response. -0.41. In the year 2005, what is the difference between the Value added (% of GDP) in Gabon and Value added (% of GDP) in Gambia, The?
Make the answer very short. -4.74. In the year 2005, what is the difference between the Value added (% of GDP) of Gabon and Value added (% of GDP) of Ireland?
Keep it short and to the point. -19.9. In the year 2005, what is the difference between the Value added (% of GDP) of Gabon and Value added (% of GDP) of Slovenia?
Your answer should be compact. -21.02. In the year 2005, what is the difference between the Value added (% of GDP) of Gambia, The and Value added (% of GDP) of Ireland?
Ensure brevity in your answer.  -15.16. In the year 2005, what is the difference between the Value added (% of GDP) in Gambia, The and Value added (% of GDP) in Slovenia?
Your answer should be compact. -16.28. In the year 2005, what is the difference between the Value added (% of GDP) of Ireland and Value added (% of GDP) of Slovenia?
Provide a succinct answer. -1.12. In the year 2006, what is the difference between the Value added (% of GDP) in Gabon and Value added (% of GDP) in Gambia, The?
Your response must be concise. -4.88. In the year 2006, what is the difference between the Value added (% of GDP) of Gabon and Value added (% of GDP) of Ireland?
Offer a terse response. -18.47. In the year 2006, what is the difference between the Value added (% of GDP) in Gabon and Value added (% of GDP) in Slovenia?
Provide a short and direct response. -20.7. In the year 2006, what is the difference between the Value added (% of GDP) in Gambia, The and Value added (% of GDP) in Ireland?
Your answer should be very brief. -13.59. In the year 2006, what is the difference between the Value added (% of GDP) in Gambia, The and Value added (% of GDP) in Slovenia?
Give a very brief answer. -15.81. In the year 2006, what is the difference between the Value added (% of GDP) of Ireland and Value added (% of GDP) of Slovenia?
Your answer should be very brief. -2.23. In the year 2007, what is the difference between the Value added (% of GDP) in Gabon and Value added (% of GDP) in Gambia, The?
Ensure brevity in your answer.  -4.79. In the year 2007, what is the difference between the Value added (% of GDP) of Gabon and Value added (% of GDP) of Ireland?
Keep it short and to the point. -17.61. In the year 2007, what is the difference between the Value added (% of GDP) of Gabon and Value added (% of GDP) of Slovenia?
Your answer should be very brief. -20.61. In the year 2007, what is the difference between the Value added (% of GDP) in Gambia, The and Value added (% of GDP) in Ireland?
Your answer should be compact. -12.82. In the year 2007, what is the difference between the Value added (% of GDP) of Gambia, The and Value added (% of GDP) of Slovenia?
Ensure brevity in your answer.  -15.82. In the year 2007, what is the difference between the Value added (% of GDP) of Ireland and Value added (% of GDP) of Slovenia?
Keep it short and to the point. -3.01. In the year 2008, what is the difference between the Value added (% of GDP) of Gabon and Value added (% of GDP) of Gambia, The?
Provide a short and direct response. -4. In the year 2008, what is the difference between the Value added (% of GDP) in Gabon and Value added (% of GDP) in Ireland?
Offer a very short reply. -17.29. In the year 2008, what is the difference between the Value added (% of GDP) in Gabon and Value added (% of GDP) in Slovenia?
Your answer should be very brief. -19.56. In the year 2008, what is the difference between the Value added (% of GDP) of Gambia, The and Value added (% of GDP) of Ireland?
Provide a short and direct response. -13.3. In the year 2008, what is the difference between the Value added (% of GDP) of Gambia, The and Value added (% of GDP) of Slovenia?
Your response must be concise. -15.57. In the year 2008, what is the difference between the Value added (% of GDP) in Ireland and Value added (% of GDP) in Slovenia?
Your answer should be compact. -2.27. In the year 2009, what is the difference between the Value added (% of GDP) of Gabon and Value added (% of GDP) of Gambia, The?
Give a very brief answer. -2.47. In the year 2009, what is the difference between the Value added (% of GDP) in Gabon and Value added (% of GDP) in Ireland?
Keep it short and to the point. -19.68. In the year 2009, what is the difference between the Value added (% of GDP) of Gabon and Value added (% of GDP) of Slovenia?
Keep it short and to the point. -16.46. In the year 2009, what is the difference between the Value added (% of GDP) of Gambia, The and Value added (% of GDP) of Ireland?
Offer a terse response. -17.21. In the year 2009, what is the difference between the Value added (% of GDP) in Gambia, The and Value added (% of GDP) in Slovenia?
Give a very brief answer. -13.99. In the year 2009, what is the difference between the Value added (% of GDP) in Ireland and Value added (% of GDP) in Slovenia?
Your answer should be very brief. 3.21. In the year 2010, what is the difference between the Value added (% of GDP) in Gabon and Value added (% of GDP) in Gambia, The?
Your answer should be very brief. -3.05. In the year 2010, what is the difference between the Value added (% of GDP) in Gabon and Value added (% of GDP) in Ireland?
Give a very brief answer. -20.09. In the year 2010, what is the difference between the Value added (% of GDP) in Gabon and Value added (% of GDP) in Slovenia?
Offer a terse response. -18.04. In the year 2010, what is the difference between the Value added (% of GDP) of Gambia, The and Value added (% of GDP) of Ireland?
Give a very brief answer. -17.04. In the year 2010, what is the difference between the Value added (% of GDP) in Gambia, The and Value added (% of GDP) in Slovenia?
Make the answer very short. -14.98. In the year 2010, what is the difference between the Value added (% of GDP) of Ireland and Value added (% of GDP) of Slovenia?
Your answer should be compact. 2.06. In the year 2011, what is the difference between the Value added (% of GDP) of Gabon and Value added (% of GDP) of Gambia, The?
Give a very brief answer. -3.66. In the year 2011, what is the difference between the Value added (% of GDP) in Gabon and Value added (% of GDP) in Ireland?
Ensure brevity in your answer.  -21.4. In the year 2011, what is the difference between the Value added (% of GDP) of Gabon and Value added (% of GDP) of Slovenia?
Your answer should be very brief. -18.58. In the year 2011, what is the difference between the Value added (% of GDP) in Gambia, The and Value added (% of GDP) in Ireland?
Keep it short and to the point. -17.73. In the year 2011, what is the difference between the Value added (% of GDP) in Gambia, The and Value added (% of GDP) in Slovenia?
Provide a short and direct response. -14.92. In the year 2011, what is the difference between the Value added (% of GDP) in Ireland and Value added (% of GDP) in Slovenia?
Ensure brevity in your answer.  2.82. What is the ratio of the Value added (% of GDP) of Gabon in 2004 to that in 2005?
Provide a short and direct response. 1.17. What is the ratio of the Value added (% of GDP) in Gambia, The in 2004 to that in 2005?
Keep it short and to the point. 0.85. What is the ratio of the Value added (% of GDP) in Ireland in 2004 to that in 2005?
Make the answer very short. 1.07. What is the ratio of the Value added (% of GDP) of Slovenia in 2004 to that in 2005?
Your answer should be compact. 1.04. What is the ratio of the Value added (% of GDP) in Gabon in 2004 to that in 2006?
Offer a terse response. 1.09. What is the ratio of the Value added (% of GDP) of Gambia, The in 2004 to that in 2006?
Offer a terse response. 0.81. What is the ratio of the Value added (% of GDP) in Ireland in 2004 to that in 2006?
Offer a very short reply. 1.14. What is the ratio of the Value added (% of GDP) in Slovenia in 2004 to that in 2006?
Give a very brief answer. 1.05. What is the ratio of the Value added (% of GDP) in Gabon in 2004 to that in 2007?
Offer a very short reply. 1.1. What is the ratio of the Value added (% of GDP) in Gambia, The in 2004 to that in 2007?
Ensure brevity in your answer.  0.82. What is the ratio of the Value added (% of GDP) of Ireland in 2004 to that in 2007?
Your answer should be compact. 1.19. What is the ratio of the Value added (% of GDP) of Slovenia in 2004 to that in 2007?
Give a very brief answer. 1.05. What is the ratio of the Value added (% of GDP) in Gabon in 2004 to that in 2008?
Your response must be concise. 1.25. What is the ratio of the Value added (% of GDP) in Gambia, The in 2004 to that in 2008?
Ensure brevity in your answer.  0.97. What is the ratio of the Value added (% of GDP) of Ireland in 2004 to that in 2008?
Your answer should be compact. 1.22. What is the ratio of the Value added (% of GDP) of Slovenia in 2004 to that in 2008?
Make the answer very short. 1.12. What is the ratio of the Value added (% of GDP) in Gabon in 2004 to that in 2009?
Your answer should be very brief. 0.96. What is the ratio of the Value added (% of GDP) of Gambia, The in 2004 to that in 2009?
Make the answer very short. 1.11. What is the ratio of the Value added (% of GDP) of Ireland in 2004 to that in 2009?
Keep it short and to the point. 1.06. What is the ratio of the Value added (% of GDP) in Slovenia in 2004 to that in 2009?
Make the answer very short. 1.25. What is the ratio of the Value added (% of GDP) of Gabon in 2004 to that in 2010?
Your response must be concise. 1.4. What is the ratio of the Value added (% of GDP) of Gambia, The in 2004 to that in 2010?
Make the answer very short. 1.19. What is the ratio of the Value added (% of GDP) of Ireland in 2004 to that in 2010?
Provide a succinct answer. 1.08. What is the ratio of the Value added (% of GDP) of Slovenia in 2004 to that in 2010?
Ensure brevity in your answer.  1.21. What is the ratio of the Value added (% of GDP) in Gabon in 2004 to that in 2011?
Keep it short and to the point. 1.25. What is the ratio of the Value added (% of GDP) of Gambia, The in 2004 to that in 2011?
Keep it short and to the point. 1.02. What is the ratio of the Value added (% of GDP) of Ireland in 2004 to that in 2011?
Keep it short and to the point. 1.01. What is the ratio of the Value added (% of GDP) of Slovenia in 2004 to that in 2011?
Give a very brief answer. 1.17. What is the ratio of the Value added (% of GDP) of Gambia, The in 2005 to that in 2006?
Ensure brevity in your answer.  0.96. What is the ratio of the Value added (% of GDP) of Ireland in 2005 to that in 2006?
Offer a very short reply. 1.06. What is the ratio of the Value added (% of GDP) of Gabon in 2005 to that in 2007?
Your response must be concise. 0.94. What is the ratio of the Value added (% of GDP) of Gambia, The in 2005 to that in 2007?
Ensure brevity in your answer.  0.97. What is the ratio of the Value added (% of GDP) of Ireland in 2005 to that in 2007?
Give a very brief answer. 1.11. What is the ratio of the Value added (% of GDP) in Slovenia in 2005 to that in 2007?
Your answer should be very brief. 1.01. What is the ratio of the Value added (% of GDP) of Gabon in 2005 to that in 2008?
Provide a succinct answer. 1.07. What is the ratio of the Value added (% of GDP) in Gambia, The in 2005 to that in 2008?
Offer a terse response. 1.14. What is the ratio of the Value added (% of GDP) of Ireland in 2005 to that in 2008?
Provide a succinct answer. 1.14. What is the ratio of the Value added (% of GDP) of Slovenia in 2005 to that in 2008?
Offer a very short reply. 1.07. What is the ratio of the Value added (% of GDP) of Gabon in 2005 to that in 2009?
Offer a terse response. 0.82. What is the ratio of the Value added (% of GDP) in Gambia, The in 2005 to that in 2009?
Keep it short and to the point. 1.31. What is the ratio of the Value added (% of GDP) in Ireland in 2005 to that in 2009?
Provide a succinct answer. 0.99. What is the ratio of the Value added (% of GDP) of Slovenia in 2005 to that in 2009?
Offer a terse response. 1.2. What is the ratio of the Value added (% of GDP) in Gabon in 2005 to that in 2010?
Offer a very short reply. 1.2. What is the ratio of the Value added (% of GDP) of Gambia, The in 2005 to that in 2010?
Your answer should be very brief. 1.41. What is the ratio of the Value added (% of GDP) of Ireland in 2005 to that in 2010?
Ensure brevity in your answer.  1.01. What is the ratio of the Value added (% of GDP) in Slovenia in 2005 to that in 2010?
Give a very brief answer. 1.17. What is the ratio of the Value added (% of GDP) in Gabon in 2005 to that in 2011?
Provide a succinct answer. 1.07. What is the ratio of the Value added (% of GDP) in Gambia, The in 2005 to that in 2011?
Keep it short and to the point. 1.21. What is the ratio of the Value added (% of GDP) in Ireland in 2005 to that in 2011?
Your answer should be compact. 0.94. What is the ratio of the Value added (% of GDP) in Slovenia in 2005 to that in 2011?
Ensure brevity in your answer.  1.12. What is the ratio of the Value added (% of GDP) in Gabon in 2006 to that in 2007?
Keep it short and to the point. 1.01. What is the ratio of the Value added (% of GDP) in Gambia, The in 2006 to that in 2007?
Offer a terse response. 1.02. What is the ratio of the Value added (% of GDP) in Ireland in 2006 to that in 2007?
Make the answer very short. 1.04. What is the ratio of the Value added (% of GDP) in Gabon in 2006 to that in 2008?
Ensure brevity in your answer.  1.15. What is the ratio of the Value added (% of GDP) in Gambia, The in 2006 to that in 2008?
Give a very brief answer. 1.19. What is the ratio of the Value added (% of GDP) in Ireland in 2006 to that in 2008?
Your answer should be compact. 1.08. What is the ratio of the Value added (% of GDP) in Slovenia in 2006 to that in 2008?
Provide a short and direct response. 1.07. What is the ratio of the Value added (% of GDP) in Gabon in 2006 to that in 2009?
Offer a terse response. 0.88. What is the ratio of the Value added (% of GDP) in Gambia, The in 2006 to that in 2009?
Keep it short and to the point. 1.37. What is the ratio of the Value added (% of GDP) of Ireland in 2006 to that in 2009?
Your answer should be compact. 0.93. What is the ratio of the Value added (% of GDP) in Slovenia in 2006 to that in 2009?
Make the answer very short. 1.2. What is the ratio of the Value added (% of GDP) of Gabon in 2006 to that in 2010?
Provide a succinct answer. 1.29. What is the ratio of the Value added (% of GDP) in Gambia, The in 2006 to that in 2010?
Provide a succinct answer. 1.47. What is the ratio of the Value added (% of GDP) in Ireland in 2006 to that in 2010?
Your answer should be compact. 0.95. What is the ratio of the Value added (% of GDP) in Slovenia in 2006 to that in 2010?
Make the answer very short. 1.16. What is the ratio of the Value added (% of GDP) in Gabon in 2006 to that in 2011?
Offer a very short reply. 1.15. What is the ratio of the Value added (% of GDP) in Gambia, The in 2006 to that in 2011?
Keep it short and to the point. 1.26. What is the ratio of the Value added (% of GDP) in Ireland in 2006 to that in 2011?
Make the answer very short. 0.89. What is the ratio of the Value added (% of GDP) in Slovenia in 2006 to that in 2011?
Give a very brief answer. 1.12. What is the ratio of the Value added (% of GDP) in Gabon in 2007 to that in 2008?
Ensure brevity in your answer.  1.13. What is the ratio of the Value added (% of GDP) in Gambia, The in 2007 to that in 2008?
Your response must be concise. 1.17. What is the ratio of the Value added (% of GDP) of Ireland in 2007 to that in 2008?
Provide a succinct answer. 1.03. What is the ratio of the Value added (% of GDP) of Slovenia in 2007 to that in 2008?
Give a very brief answer. 1.06. What is the ratio of the Value added (% of GDP) in Gabon in 2007 to that in 2009?
Your answer should be very brief. 0.87. What is the ratio of the Value added (% of GDP) of Gambia, The in 2007 to that in 2009?
Your answer should be compact. 1.35. What is the ratio of the Value added (% of GDP) of Ireland in 2007 to that in 2009?
Your answer should be very brief. 0.89. What is the ratio of the Value added (% of GDP) of Slovenia in 2007 to that in 2009?
Offer a very short reply. 1.19. What is the ratio of the Value added (% of GDP) of Gabon in 2007 to that in 2010?
Give a very brief answer. 1.27. What is the ratio of the Value added (% of GDP) of Gambia, The in 2007 to that in 2010?
Your response must be concise. 1.45. What is the ratio of the Value added (% of GDP) of Ireland in 2007 to that in 2010?
Your answer should be very brief. 0.91. What is the ratio of the Value added (% of GDP) in Slovenia in 2007 to that in 2010?
Offer a very short reply. 1.16. What is the ratio of the Value added (% of GDP) of Gabon in 2007 to that in 2011?
Provide a succinct answer. 1.13. What is the ratio of the Value added (% of GDP) of Gambia, The in 2007 to that in 2011?
Make the answer very short. 1.24. What is the ratio of the Value added (% of GDP) of Ireland in 2007 to that in 2011?
Your answer should be compact. 0.85. What is the ratio of the Value added (% of GDP) of Slovenia in 2007 to that in 2011?
Your answer should be compact. 1.11. What is the ratio of the Value added (% of GDP) of Gabon in 2008 to that in 2009?
Your answer should be compact. 0.77. What is the ratio of the Value added (% of GDP) in Gambia, The in 2008 to that in 2009?
Keep it short and to the point. 1.15. What is the ratio of the Value added (% of GDP) in Ireland in 2008 to that in 2009?
Offer a terse response. 0.86. What is the ratio of the Value added (% of GDP) in Slovenia in 2008 to that in 2009?
Your answer should be very brief. 1.12. What is the ratio of the Value added (% of GDP) in Gabon in 2008 to that in 2010?
Provide a short and direct response. 1.12. What is the ratio of the Value added (% of GDP) of Gambia, The in 2008 to that in 2010?
Give a very brief answer. 1.23. What is the ratio of the Value added (% of GDP) in Ireland in 2008 to that in 2010?
Your answer should be very brief. 0.89. What is the ratio of the Value added (% of GDP) of Slovenia in 2008 to that in 2010?
Offer a terse response. 1.09. What is the ratio of the Value added (% of GDP) in Gambia, The in 2008 to that in 2011?
Your answer should be very brief. 1.06. What is the ratio of the Value added (% of GDP) of Ireland in 2008 to that in 2011?
Your response must be concise. 0.83. What is the ratio of the Value added (% of GDP) in Slovenia in 2008 to that in 2011?
Your response must be concise. 1.05. What is the ratio of the Value added (% of GDP) of Gabon in 2009 to that in 2010?
Your answer should be compact. 1.46. What is the ratio of the Value added (% of GDP) of Gambia, The in 2009 to that in 2010?
Give a very brief answer. 1.07. What is the ratio of the Value added (% of GDP) in Ireland in 2009 to that in 2010?
Provide a succinct answer. 1.03. What is the ratio of the Value added (% of GDP) of Slovenia in 2009 to that in 2010?
Give a very brief answer. 0.97. What is the ratio of the Value added (% of GDP) in Gabon in 2009 to that in 2011?
Your answer should be very brief. 1.3. What is the ratio of the Value added (% of GDP) in Gambia, The in 2009 to that in 2011?
Make the answer very short. 0.92. What is the ratio of the Value added (% of GDP) of Ireland in 2009 to that in 2011?
Your answer should be compact. 0.96. What is the ratio of the Value added (% of GDP) in Slovenia in 2009 to that in 2011?
Ensure brevity in your answer.  0.93. What is the ratio of the Value added (% of GDP) of Gabon in 2010 to that in 2011?
Make the answer very short. 0.89. What is the ratio of the Value added (% of GDP) in Gambia, The in 2010 to that in 2011?
Your answer should be compact. 0.86. What is the ratio of the Value added (% of GDP) of Ireland in 2010 to that in 2011?
Give a very brief answer. 0.93. What is the ratio of the Value added (% of GDP) of Slovenia in 2010 to that in 2011?
Offer a very short reply. 0.96. What is the difference between the highest and the second highest Value added (% of GDP) in Gabon?
Keep it short and to the point. 0.11. What is the difference between the highest and the second highest Value added (% of GDP) in Gambia, The?
Offer a very short reply. 0.13. What is the difference between the highest and the second highest Value added (% of GDP) of Ireland?
Make the answer very short. 0.3. What is the difference between the highest and the second highest Value added (% of GDP) in Slovenia?
Give a very brief answer. 0.92. What is the difference between the highest and the lowest Value added (% of GDP) of Gabon?
Your answer should be compact. 0.97. What is the difference between the highest and the lowest Value added (% of GDP) in Gambia, The?
Your answer should be very brief. 2.44. What is the difference between the highest and the lowest Value added (% of GDP) of Ireland?
Your answer should be very brief. 4.4. What is the difference between the highest and the lowest Value added (% of GDP) of Slovenia?
Your answer should be very brief. 4.93. 